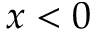<formula> <loc_0><loc_0><loc_500><loc_500>x < 0</formula> 